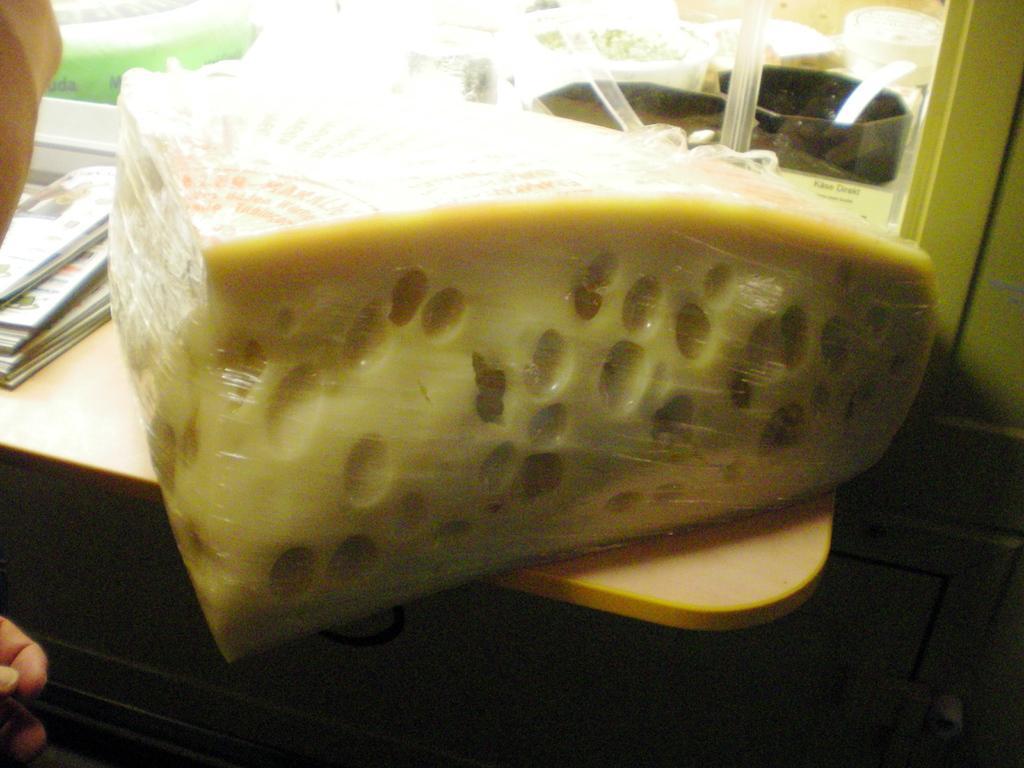What is the main subject of the image? The main subject of the image is a block of cheese. Where is the block of cheese located? The block of cheese is on a table. What type of polish is being applied to the horse in the image? There is no horse or polish present in the image; it only features a block of cheese on a table. 